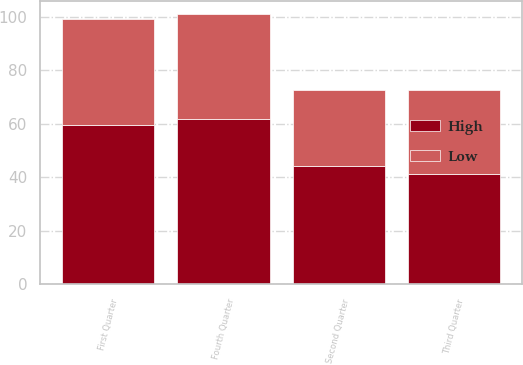Convert chart to OTSL. <chart><loc_0><loc_0><loc_500><loc_500><stacked_bar_chart><ecel><fcel>First Quarter<fcel>Second Quarter<fcel>Third Quarter<fcel>Fourth Quarter<nl><fcel>High<fcel>59.47<fcel>44.45<fcel>41.32<fcel>61.74<nl><fcel>Low<fcel>39.72<fcel>28.36<fcel>31.51<fcel>39.32<nl></chart> 